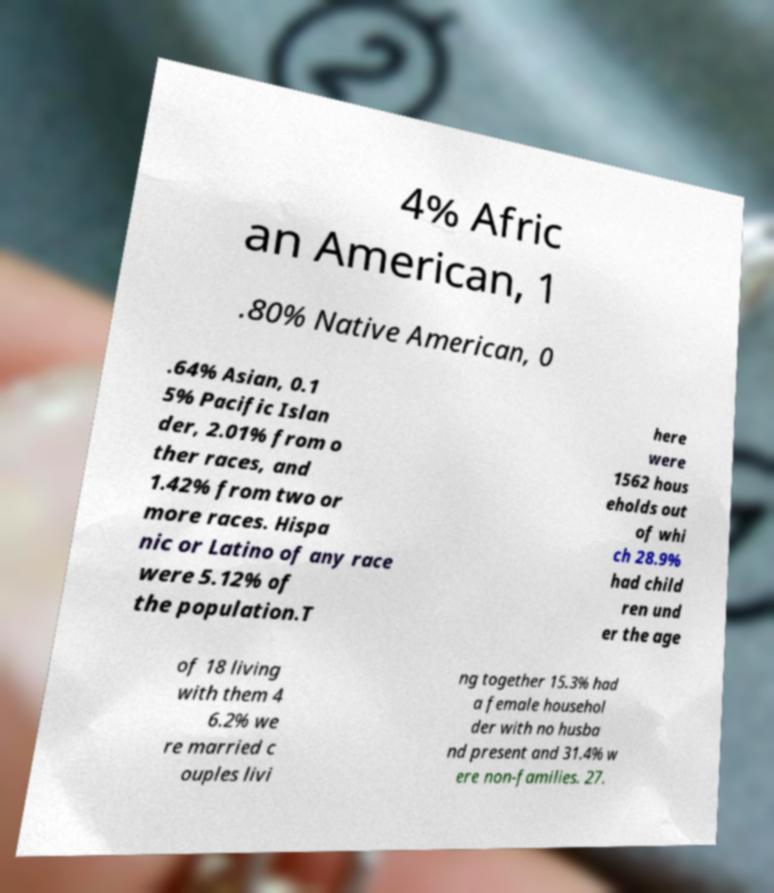Could you extract and type out the text from this image? 4% Afric an American, 1 .80% Native American, 0 .64% Asian, 0.1 5% Pacific Islan der, 2.01% from o ther races, and 1.42% from two or more races. Hispa nic or Latino of any race were 5.12% of the population.T here were 1562 hous eholds out of whi ch 28.9% had child ren und er the age of 18 living with them 4 6.2% we re married c ouples livi ng together 15.3% had a female househol der with no husba nd present and 31.4% w ere non-families. 27. 